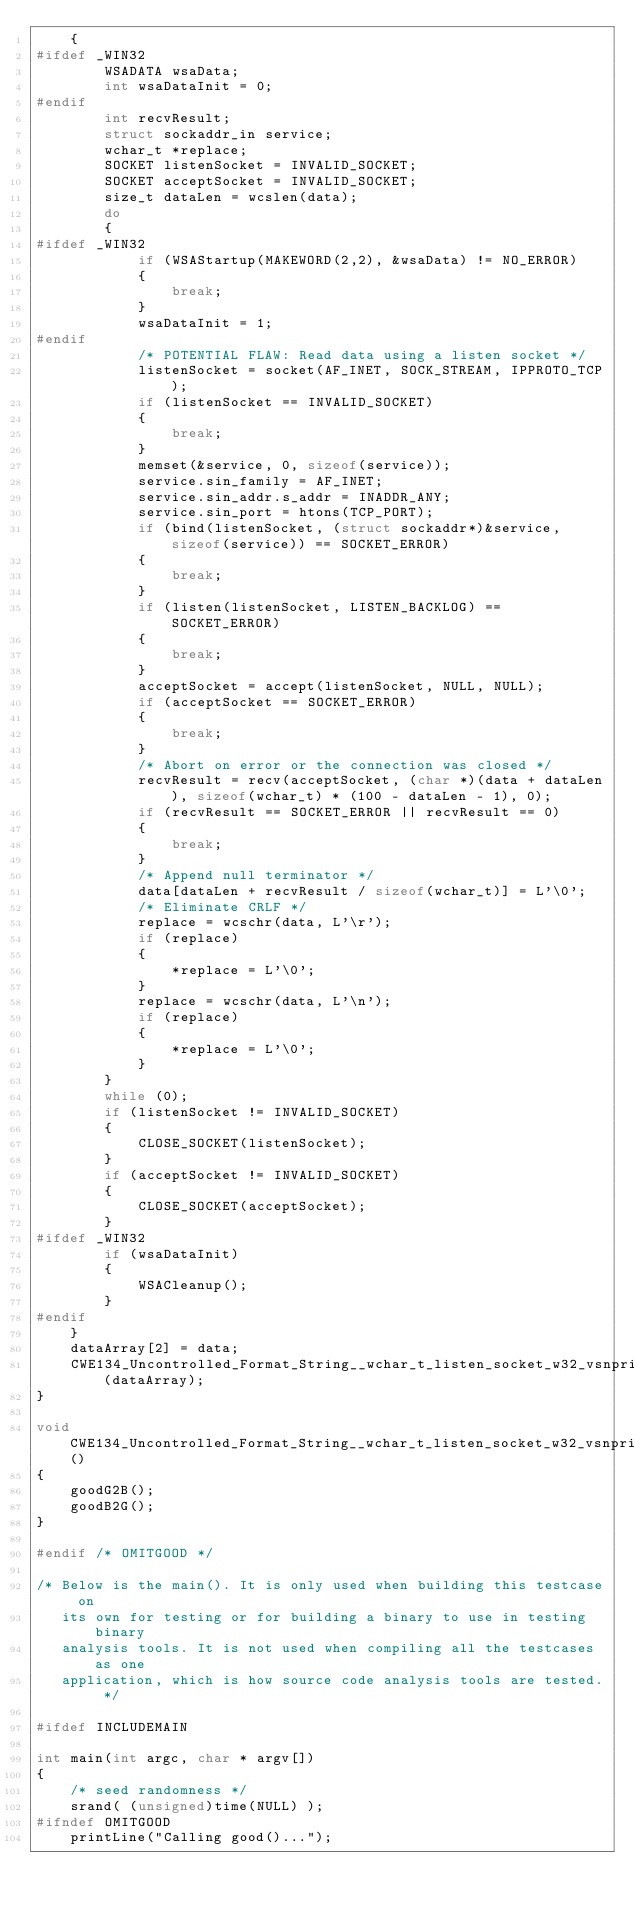<code> <loc_0><loc_0><loc_500><loc_500><_C_>    {
#ifdef _WIN32
        WSADATA wsaData;
        int wsaDataInit = 0;
#endif
        int recvResult;
        struct sockaddr_in service;
        wchar_t *replace;
        SOCKET listenSocket = INVALID_SOCKET;
        SOCKET acceptSocket = INVALID_SOCKET;
        size_t dataLen = wcslen(data);
        do
        {
#ifdef _WIN32
            if (WSAStartup(MAKEWORD(2,2), &wsaData) != NO_ERROR)
            {
                break;
            }
            wsaDataInit = 1;
#endif
            /* POTENTIAL FLAW: Read data using a listen socket */
            listenSocket = socket(AF_INET, SOCK_STREAM, IPPROTO_TCP);
            if (listenSocket == INVALID_SOCKET)
            {
                break;
            }
            memset(&service, 0, sizeof(service));
            service.sin_family = AF_INET;
            service.sin_addr.s_addr = INADDR_ANY;
            service.sin_port = htons(TCP_PORT);
            if (bind(listenSocket, (struct sockaddr*)&service, sizeof(service)) == SOCKET_ERROR)
            {
                break;
            }
            if (listen(listenSocket, LISTEN_BACKLOG) == SOCKET_ERROR)
            {
                break;
            }
            acceptSocket = accept(listenSocket, NULL, NULL);
            if (acceptSocket == SOCKET_ERROR)
            {
                break;
            }
            /* Abort on error or the connection was closed */
            recvResult = recv(acceptSocket, (char *)(data + dataLen), sizeof(wchar_t) * (100 - dataLen - 1), 0);
            if (recvResult == SOCKET_ERROR || recvResult == 0)
            {
                break;
            }
            /* Append null terminator */
            data[dataLen + recvResult / sizeof(wchar_t)] = L'\0';
            /* Eliminate CRLF */
            replace = wcschr(data, L'\r');
            if (replace)
            {
                *replace = L'\0';
            }
            replace = wcschr(data, L'\n');
            if (replace)
            {
                *replace = L'\0';
            }
        }
        while (0);
        if (listenSocket != INVALID_SOCKET)
        {
            CLOSE_SOCKET(listenSocket);
        }
        if (acceptSocket != INVALID_SOCKET)
        {
            CLOSE_SOCKET(acceptSocket);
        }
#ifdef _WIN32
        if (wsaDataInit)
        {
            WSACleanup();
        }
#endif
    }
    dataArray[2] = data;
    CWE134_Uncontrolled_Format_String__wchar_t_listen_socket_w32_vsnprintf_66b_goodB2GSink(dataArray);
}

void CWE134_Uncontrolled_Format_String__wchar_t_listen_socket_w32_vsnprintf_66_good()
{
    goodG2B();
    goodB2G();
}

#endif /* OMITGOOD */

/* Below is the main(). It is only used when building this testcase on
   its own for testing or for building a binary to use in testing binary
   analysis tools. It is not used when compiling all the testcases as one
   application, which is how source code analysis tools are tested. */

#ifdef INCLUDEMAIN

int main(int argc, char * argv[])
{
    /* seed randomness */
    srand( (unsigned)time(NULL) );
#ifndef OMITGOOD
    printLine("Calling good()...");</code> 